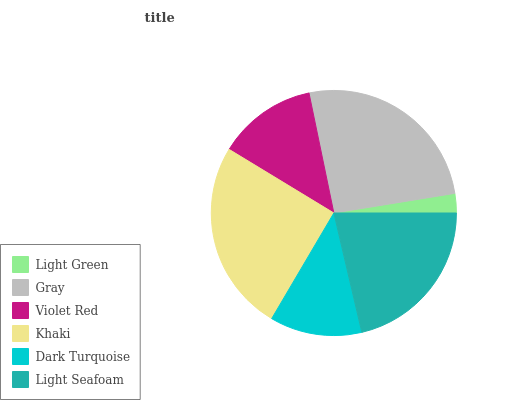Is Light Green the minimum?
Answer yes or no. Yes. Is Gray the maximum?
Answer yes or no. Yes. Is Violet Red the minimum?
Answer yes or no. No. Is Violet Red the maximum?
Answer yes or no. No. Is Gray greater than Violet Red?
Answer yes or no. Yes. Is Violet Red less than Gray?
Answer yes or no. Yes. Is Violet Red greater than Gray?
Answer yes or no. No. Is Gray less than Violet Red?
Answer yes or no. No. Is Light Seafoam the high median?
Answer yes or no. Yes. Is Violet Red the low median?
Answer yes or no. Yes. Is Violet Red the high median?
Answer yes or no. No. Is Khaki the low median?
Answer yes or no. No. 